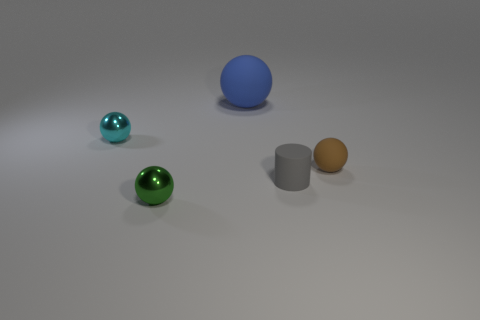Subtract all tiny spheres. How many spheres are left? 1 Subtract all cyan spheres. How many spheres are left? 3 Add 3 big gray metal blocks. How many objects exist? 8 Subtract all gray cubes. How many cyan spheres are left? 1 Subtract all big gray things. Subtract all gray objects. How many objects are left? 4 Add 2 tiny green spheres. How many tiny green spheres are left? 3 Add 4 tiny green shiny spheres. How many tiny green shiny spheres exist? 5 Subtract 0 red spheres. How many objects are left? 5 Subtract all spheres. How many objects are left? 1 Subtract 2 spheres. How many spheres are left? 2 